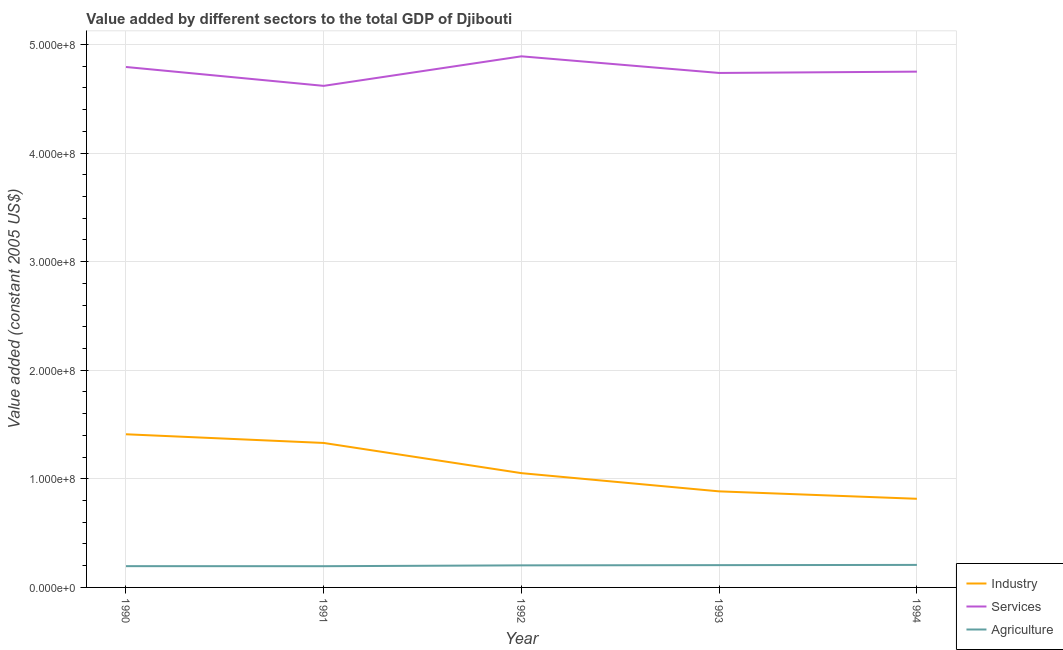Does the line corresponding to value added by industrial sector intersect with the line corresponding to value added by agricultural sector?
Provide a succinct answer. No. Is the number of lines equal to the number of legend labels?
Offer a terse response. Yes. What is the value added by services in 1990?
Ensure brevity in your answer.  4.79e+08. Across all years, what is the maximum value added by industrial sector?
Provide a short and direct response. 1.41e+08. Across all years, what is the minimum value added by industrial sector?
Make the answer very short. 8.16e+07. In which year was the value added by services minimum?
Offer a very short reply. 1991. What is the total value added by industrial sector in the graph?
Make the answer very short. 5.49e+08. What is the difference between the value added by industrial sector in 1990 and that in 1994?
Ensure brevity in your answer.  5.94e+07. What is the difference between the value added by services in 1994 and the value added by agricultural sector in 1992?
Keep it short and to the point. 4.55e+08. What is the average value added by agricultural sector per year?
Give a very brief answer. 2.01e+07. In the year 1993, what is the difference between the value added by industrial sector and value added by agricultural sector?
Ensure brevity in your answer.  6.79e+07. What is the ratio of the value added by agricultural sector in 1990 to that in 1994?
Provide a short and direct response. 0.94. Is the difference between the value added by agricultural sector in 1991 and 1994 greater than the difference between the value added by services in 1991 and 1994?
Provide a succinct answer. Yes. What is the difference between the highest and the second highest value added by industrial sector?
Provide a short and direct response. 8.00e+06. What is the difference between the highest and the lowest value added by services?
Provide a succinct answer. 2.72e+07. In how many years, is the value added by services greater than the average value added by services taken over all years?
Provide a succinct answer. 2. Is the sum of the value added by industrial sector in 1992 and 1994 greater than the maximum value added by agricultural sector across all years?
Keep it short and to the point. Yes. Is the value added by agricultural sector strictly greater than the value added by services over the years?
Provide a succinct answer. No. How many lines are there?
Offer a very short reply. 3. What is the difference between two consecutive major ticks on the Y-axis?
Ensure brevity in your answer.  1.00e+08. Are the values on the major ticks of Y-axis written in scientific E-notation?
Provide a succinct answer. Yes. Does the graph contain any zero values?
Ensure brevity in your answer.  No. Does the graph contain grids?
Offer a terse response. Yes. Where does the legend appear in the graph?
Offer a terse response. Bottom right. How many legend labels are there?
Keep it short and to the point. 3. How are the legend labels stacked?
Offer a terse response. Vertical. What is the title of the graph?
Offer a terse response. Value added by different sectors to the total GDP of Djibouti. Does "Solid fuel" appear as one of the legend labels in the graph?
Ensure brevity in your answer.  No. What is the label or title of the Y-axis?
Your answer should be compact. Value added (constant 2005 US$). What is the Value added (constant 2005 US$) of Industry in 1990?
Your answer should be very brief. 1.41e+08. What is the Value added (constant 2005 US$) of Services in 1990?
Offer a terse response. 4.79e+08. What is the Value added (constant 2005 US$) in Agriculture in 1990?
Offer a terse response. 1.96e+07. What is the Value added (constant 2005 US$) in Industry in 1991?
Keep it short and to the point. 1.33e+08. What is the Value added (constant 2005 US$) of Services in 1991?
Offer a very short reply. 4.62e+08. What is the Value added (constant 2005 US$) of Agriculture in 1991?
Make the answer very short. 1.95e+07. What is the Value added (constant 2005 US$) in Industry in 1992?
Make the answer very short. 1.05e+08. What is the Value added (constant 2005 US$) in Services in 1992?
Provide a short and direct response. 4.89e+08. What is the Value added (constant 2005 US$) of Agriculture in 1992?
Offer a terse response. 2.03e+07. What is the Value added (constant 2005 US$) of Industry in 1993?
Provide a short and direct response. 8.85e+07. What is the Value added (constant 2005 US$) in Services in 1993?
Your answer should be very brief. 4.74e+08. What is the Value added (constant 2005 US$) in Agriculture in 1993?
Your response must be concise. 2.05e+07. What is the Value added (constant 2005 US$) of Industry in 1994?
Give a very brief answer. 8.16e+07. What is the Value added (constant 2005 US$) in Services in 1994?
Provide a short and direct response. 4.75e+08. What is the Value added (constant 2005 US$) of Agriculture in 1994?
Offer a very short reply. 2.07e+07. Across all years, what is the maximum Value added (constant 2005 US$) of Industry?
Provide a short and direct response. 1.41e+08. Across all years, what is the maximum Value added (constant 2005 US$) of Services?
Your answer should be very brief. 4.89e+08. Across all years, what is the maximum Value added (constant 2005 US$) in Agriculture?
Offer a terse response. 2.07e+07. Across all years, what is the minimum Value added (constant 2005 US$) in Industry?
Your answer should be compact. 8.16e+07. Across all years, what is the minimum Value added (constant 2005 US$) of Services?
Provide a succinct answer. 4.62e+08. Across all years, what is the minimum Value added (constant 2005 US$) of Agriculture?
Make the answer very short. 1.95e+07. What is the total Value added (constant 2005 US$) in Industry in the graph?
Give a very brief answer. 5.49e+08. What is the total Value added (constant 2005 US$) in Services in the graph?
Your answer should be very brief. 2.38e+09. What is the total Value added (constant 2005 US$) of Agriculture in the graph?
Keep it short and to the point. 1.01e+08. What is the difference between the Value added (constant 2005 US$) of Industry in 1990 and that in 1991?
Provide a short and direct response. 8.00e+06. What is the difference between the Value added (constant 2005 US$) in Services in 1990 and that in 1991?
Give a very brief answer. 1.74e+07. What is the difference between the Value added (constant 2005 US$) of Agriculture in 1990 and that in 1991?
Your answer should be very brief. 3.64e+04. What is the difference between the Value added (constant 2005 US$) in Industry in 1990 and that in 1992?
Provide a succinct answer. 3.58e+07. What is the difference between the Value added (constant 2005 US$) of Services in 1990 and that in 1992?
Offer a very short reply. -9.82e+06. What is the difference between the Value added (constant 2005 US$) in Agriculture in 1990 and that in 1992?
Your response must be concise. -7.27e+05. What is the difference between the Value added (constant 2005 US$) of Industry in 1990 and that in 1993?
Offer a very short reply. 5.26e+07. What is the difference between the Value added (constant 2005 US$) of Services in 1990 and that in 1993?
Your answer should be compact. 5.50e+06. What is the difference between the Value added (constant 2005 US$) of Agriculture in 1990 and that in 1993?
Your answer should be compact. -9.41e+05. What is the difference between the Value added (constant 2005 US$) of Industry in 1990 and that in 1994?
Ensure brevity in your answer.  5.94e+07. What is the difference between the Value added (constant 2005 US$) in Services in 1990 and that in 1994?
Ensure brevity in your answer.  4.29e+06. What is the difference between the Value added (constant 2005 US$) in Agriculture in 1990 and that in 1994?
Offer a very short reply. -1.15e+06. What is the difference between the Value added (constant 2005 US$) of Industry in 1991 and that in 1992?
Ensure brevity in your answer.  2.78e+07. What is the difference between the Value added (constant 2005 US$) in Services in 1991 and that in 1992?
Keep it short and to the point. -2.72e+07. What is the difference between the Value added (constant 2005 US$) of Agriculture in 1991 and that in 1992?
Provide a succinct answer. -7.63e+05. What is the difference between the Value added (constant 2005 US$) in Industry in 1991 and that in 1993?
Keep it short and to the point. 4.46e+07. What is the difference between the Value added (constant 2005 US$) in Services in 1991 and that in 1993?
Provide a succinct answer. -1.19e+07. What is the difference between the Value added (constant 2005 US$) of Agriculture in 1991 and that in 1993?
Ensure brevity in your answer.  -9.78e+05. What is the difference between the Value added (constant 2005 US$) of Industry in 1991 and that in 1994?
Offer a very short reply. 5.14e+07. What is the difference between the Value added (constant 2005 US$) in Services in 1991 and that in 1994?
Your answer should be very brief. -1.31e+07. What is the difference between the Value added (constant 2005 US$) in Agriculture in 1991 and that in 1994?
Provide a short and direct response. -1.19e+06. What is the difference between the Value added (constant 2005 US$) of Industry in 1992 and that in 1993?
Provide a succinct answer. 1.68e+07. What is the difference between the Value added (constant 2005 US$) in Services in 1992 and that in 1993?
Keep it short and to the point. 1.53e+07. What is the difference between the Value added (constant 2005 US$) in Agriculture in 1992 and that in 1993?
Ensure brevity in your answer.  -2.15e+05. What is the difference between the Value added (constant 2005 US$) in Industry in 1992 and that in 1994?
Make the answer very short. 2.36e+07. What is the difference between the Value added (constant 2005 US$) in Services in 1992 and that in 1994?
Give a very brief answer. 1.41e+07. What is the difference between the Value added (constant 2005 US$) of Agriculture in 1992 and that in 1994?
Ensure brevity in your answer.  -4.26e+05. What is the difference between the Value added (constant 2005 US$) of Industry in 1993 and that in 1994?
Ensure brevity in your answer.  6.83e+06. What is the difference between the Value added (constant 2005 US$) of Services in 1993 and that in 1994?
Ensure brevity in your answer.  -1.21e+06. What is the difference between the Value added (constant 2005 US$) of Agriculture in 1993 and that in 1994?
Offer a terse response. -2.11e+05. What is the difference between the Value added (constant 2005 US$) in Industry in 1990 and the Value added (constant 2005 US$) in Services in 1991?
Offer a terse response. -3.21e+08. What is the difference between the Value added (constant 2005 US$) in Industry in 1990 and the Value added (constant 2005 US$) in Agriculture in 1991?
Ensure brevity in your answer.  1.21e+08. What is the difference between the Value added (constant 2005 US$) in Services in 1990 and the Value added (constant 2005 US$) in Agriculture in 1991?
Your response must be concise. 4.60e+08. What is the difference between the Value added (constant 2005 US$) in Industry in 1990 and the Value added (constant 2005 US$) in Services in 1992?
Your response must be concise. -3.48e+08. What is the difference between the Value added (constant 2005 US$) of Industry in 1990 and the Value added (constant 2005 US$) of Agriculture in 1992?
Offer a very short reply. 1.21e+08. What is the difference between the Value added (constant 2005 US$) in Services in 1990 and the Value added (constant 2005 US$) in Agriculture in 1992?
Give a very brief answer. 4.59e+08. What is the difference between the Value added (constant 2005 US$) of Industry in 1990 and the Value added (constant 2005 US$) of Services in 1993?
Provide a short and direct response. -3.33e+08. What is the difference between the Value added (constant 2005 US$) in Industry in 1990 and the Value added (constant 2005 US$) in Agriculture in 1993?
Ensure brevity in your answer.  1.21e+08. What is the difference between the Value added (constant 2005 US$) of Services in 1990 and the Value added (constant 2005 US$) of Agriculture in 1993?
Give a very brief answer. 4.59e+08. What is the difference between the Value added (constant 2005 US$) in Industry in 1990 and the Value added (constant 2005 US$) in Services in 1994?
Your response must be concise. -3.34e+08. What is the difference between the Value added (constant 2005 US$) of Industry in 1990 and the Value added (constant 2005 US$) of Agriculture in 1994?
Provide a succinct answer. 1.20e+08. What is the difference between the Value added (constant 2005 US$) of Services in 1990 and the Value added (constant 2005 US$) of Agriculture in 1994?
Your answer should be very brief. 4.58e+08. What is the difference between the Value added (constant 2005 US$) of Industry in 1991 and the Value added (constant 2005 US$) of Services in 1992?
Your answer should be compact. -3.56e+08. What is the difference between the Value added (constant 2005 US$) in Industry in 1991 and the Value added (constant 2005 US$) in Agriculture in 1992?
Offer a very short reply. 1.13e+08. What is the difference between the Value added (constant 2005 US$) of Services in 1991 and the Value added (constant 2005 US$) of Agriculture in 1992?
Keep it short and to the point. 4.42e+08. What is the difference between the Value added (constant 2005 US$) of Industry in 1991 and the Value added (constant 2005 US$) of Services in 1993?
Your answer should be compact. -3.41e+08. What is the difference between the Value added (constant 2005 US$) of Industry in 1991 and the Value added (constant 2005 US$) of Agriculture in 1993?
Ensure brevity in your answer.  1.13e+08. What is the difference between the Value added (constant 2005 US$) in Services in 1991 and the Value added (constant 2005 US$) in Agriculture in 1993?
Provide a short and direct response. 4.41e+08. What is the difference between the Value added (constant 2005 US$) of Industry in 1991 and the Value added (constant 2005 US$) of Services in 1994?
Make the answer very short. -3.42e+08. What is the difference between the Value added (constant 2005 US$) of Industry in 1991 and the Value added (constant 2005 US$) of Agriculture in 1994?
Ensure brevity in your answer.  1.12e+08. What is the difference between the Value added (constant 2005 US$) of Services in 1991 and the Value added (constant 2005 US$) of Agriculture in 1994?
Offer a terse response. 4.41e+08. What is the difference between the Value added (constant 2005 US$) in Industry in 1992 and the Value added (constant 2005 US$) in Services in 1993?
Provide a succinct answer. -3.68e+08. What is the difference between the Value added (constant 2005 US$) in Industry in 1992 and the Value added (constant 2005 US$) in Agriculture in 1993?
Offer a very short reply. 8.47e+07. What is the difference between the Value added (constant 2005 US$) of Services in 1992 and the Value added (constant 2005 US$) of Agriculture in 1993?
Your answer should be very brief. 4.69e+08. What is the difference between the Value added (constant 2005 US$) of Industry in 1992 and the Value added (constant 2005 US$) of Services in 1994?
Give a very brief answer. -3.70e+08. What is the difference between the Value added (constant 2005 US$) of Industry in 1992 and the Value added (constant 2005 US$) of Agriculture in 1994?
Provide a succinct answer. 8.45e+07. What is the difference between the Value added (constant 2005 US$) in Services in 1992 and the Value added (constant 2005 US$) in Agriculture in 1994?
Provide a succinct answer. 4.68e+08. What is the difference between the Value added (constant 2005 US$) of Industry in 1993 and the Value added (constant 2005 US$) of Services in 1994?
Keep it short and to the point. -3.86e+08. What is the difference between the Value added (constant 2005 US$) in Industry in 1993 and the Value added (constant 2005 US$) in Agriculture in 1994?
Keep it short and to the point. 6.77e+07. What is the difference between the Value added (constant 2005 US$) in Services in 1993 and the Value added (constant 2005 US$) in Agriculture in 1994?
Offer a terse response. 4.53e+08. What is the average Value added (constant 2005 US$) in Industry per year?
Provide a succinct answer. 1.10e+08. What is the average Value added (constant 2005 US$) of Services per year?
Make the answer very short. 4.76e+08. What is the average Value added (constant 2005 US$) of Agriculture per year?
Offer a terse response. 2.01e+07. In the year 1990, what is the difference between the Value added (constant 2005 US$) in Industry and Value added (constant 2005 US$) in Services?
Keep it short and to the point. -3.38e+08. In the year 1990, what is the difference between the Value added (constant 2005 US$) in Industry and Value added (constant 2005 US$) in Agriculture?
Your answer should be very brief. 1.21e+08. In the year 1990, what is the difference between the Value added (constant 2005 US$) of Services and Value added (constant 2005 US$) of Agriculture?
Your response must be concise. 4.60e+08. In the year 1991, what is the difference between the Value added (constant 2005 US$) of Industry and Value added (constant 2005 US$) of Services?
Offer a terse response. -3.29e+08. In the year 1991, what is the difference between the Value added (constant 2005 US$) in Industry and Value added (constant 2005 US$) in Agriculture?
Keep it short and to the point. 1.13e+08. In the year 1991, what is the difference between the Value added (constant 2005 US$) of Services and Value added (constant 2005 US$) of Agriculture?
Provide a short and direct response. 4.42e+08. In the year 1992, what is the difference between the Value added (constant 2005 US$) in Industry and Value added (constant 2005 US$) in Services?
Offer a very short reply. -3.84e+08. In the year 1992, what is the difference between the Value added (constant 2005 US$) of Industry and Value added (constant 2005 US$) of Agriculture?
Keep it short and to the point. 8.49e+07. In the year 1992, what is the difference between the Value added (constant 2005 US$) of Services and Value added (constant 2005 US$) of Agriculture?
Ensure brevity in your answer.  4.69e+08. In the year 1993, what is the difference between the Value added (constant 2005 US$) of Industry and Value added (constant 2005 US$) of Services?
Your response must be concise. -3.85e+08. In the year 1993, what is the difference between the Value added (constant 2005 US$) of Industry and Value added (constant 2005 US$) of Agriculture?
Offer a terse response. 6.79e+07. In the year 1993, what is the difference between the Value added (constant 2005 US$) of Services and Value added (constant 2005 US$) of Agriculture?
Offer a terse response. 4.53e+08. In the year 1994, what is the difference between the Value added (constant 2005 US$) of Industry and Value added (constant 2005 US$) of Services?
Provide a succinct answer. -3.93e+08. In the year 1994, what is the difference between the Value added (constant 2005 US$) in Industry and Value added (constant 2005 US$) in Agriculture?
Your answer should be very brief. 6.09e+07. In the year 1994, what is the difference between the Value added (constant 2005 US$) in Services and Value added (constant 2005 US$) in Agriculture?
Your answer should be compact. 4.54e+08. What is the ratio of the Value added (constant 2005 US$) in Industry in 1990 to that in 1991?
Offer a terse response. 1.06. What is the ratio of the Value added (constant 2005 US$) of Services in 1990 to that in 1991?
Provide a short and direct response. 1.04. What is the ratio of the Value added (constant 2005 US$) in Agriculture in 1990 to that in 1991?
Provide a succinct answer. 1. What is the ratio of the Value added (constant 2005 US$) in Industry in 1990 to that in 1992?
Your answer should be very brief. 1.34. What is the ratio of the Value added (constant 2005 US$) of Services in 1990 to that in 1992?
Offer a terse response. 0.98. What is the ratio of the Value added (constant 2005 US$) of Agriculture in 1990 to that in 1992?
Offer a terse response. 0.96. What is the ratio of the Value added (constant 2005 US$) of Industry in 1990 to that in 1993?
Keep it short and to the point. 1.59. What is the ratio of the Value added (constant 2005 US$) in Services in 1990 to that in 1993?
Your answer should be very brief. 1.01. What is the ratio of the Value added (constant 2005 US$) in Agriculture in 1990 to that in 1993?
Provide a short and direct response. 0.95. What is the ratio of the Value added (constant 2005 US$) of Industry in 1990 to that in 1994?
Offer a very short reply. 1.73. What is the ratio of the Value added (constant 2005 US$) of Services in 1990 to that in 1994?
Give a very brief answer. 1.01. What is the ratio of the Value added (constant 2005 US$) in Industry in 1991 to that in 1992?
Provide a succinct answer. 1.26. What is the ratio of the Value added (constant 2005 US$) of Agriculture in 1991 to that in 1992?
Offer a very short reply. 0.96. What is the ratio of the Value added (constant 2005 US$) of Industry in 1991 to that in 1993?
Your response must be concise. 1.5. What is the ratio of the Value added (constant 2005 US$) of Services in 1991 to that in 1993?
Make the answer very short. 0.97. What is the ratio of the Value added (constant 2005 US$) of Industry in 1991 to that in 1994?
Ensure brevity in your answer.  1.63. What is the ratio of the Value added (constant 2005 US$) in Services in 1991 to that in 1994?
Ensure brevity in your answer.  0.97. What is the ratio of the Value added (constant 2005 US$) in Agriculture in 1991 to that in 1994?
Ensure brevity in your answer.  0.94. What is the ratio of the Value added (constant 2005 US$) of Industry in 1992 to that in 1993?
Your answer should be very brief. 1.19. What is the ratio of the Value added (constant 2005 US$) of Services in 1992 to that in 1993?
Provide a succinct answer. 1.03. What is the ratio of the Value added (constant 2005 US$) of Agriculture in 1992 to that in 1993?
Provide a succinct answer. 0.99. What is the ratio of the Value added (constant 2005 US$) in Industry in 1992 to that in 1994?
Provide a short and direct response. 1.29. What is the ratio of the Value added (constant 2005 US$) in Services in 1992 to that in 1994?
Provide a short and direct response. 1.03. What is the ratio of the Value added (constant 2005 US$) of Agriculture in 1992 to that in 1994?
Your response must be concise. 0.98. What is the ratio of the Value added (constant 2005 US$) in Industry in 1993 to that in 1994?
Provide a succinct answer. 1.08. What is the difference between the highest and the second highest Value added (constant 2005 US$) in Industry?
Offer a terse response. 8.00e+06. What is the difference between the highest and the second highest Value added (constant 2005 US$) of Services?
Ensure brevity in your answer.  9.82e+06. What is the difference between the highest and the second highest Value added (constant 2005 US$) of Agriculture?
Ensure brevity in your answer.  2.11e+05. What is the difference between the highest and the lowest Value added (constant 2005 US$) of Industry?
Keep it short and to the point. 5.94e+07. What is the difference between the highest and the lowest Value added (constant 2005 US$) in Services?
Provide a short and direct response. 2.72e+07. What is the difference between the highest and the lowest Value added (constant 2005 US$) of Agriculture?
Give a very brief answer. 1.19e+06. 